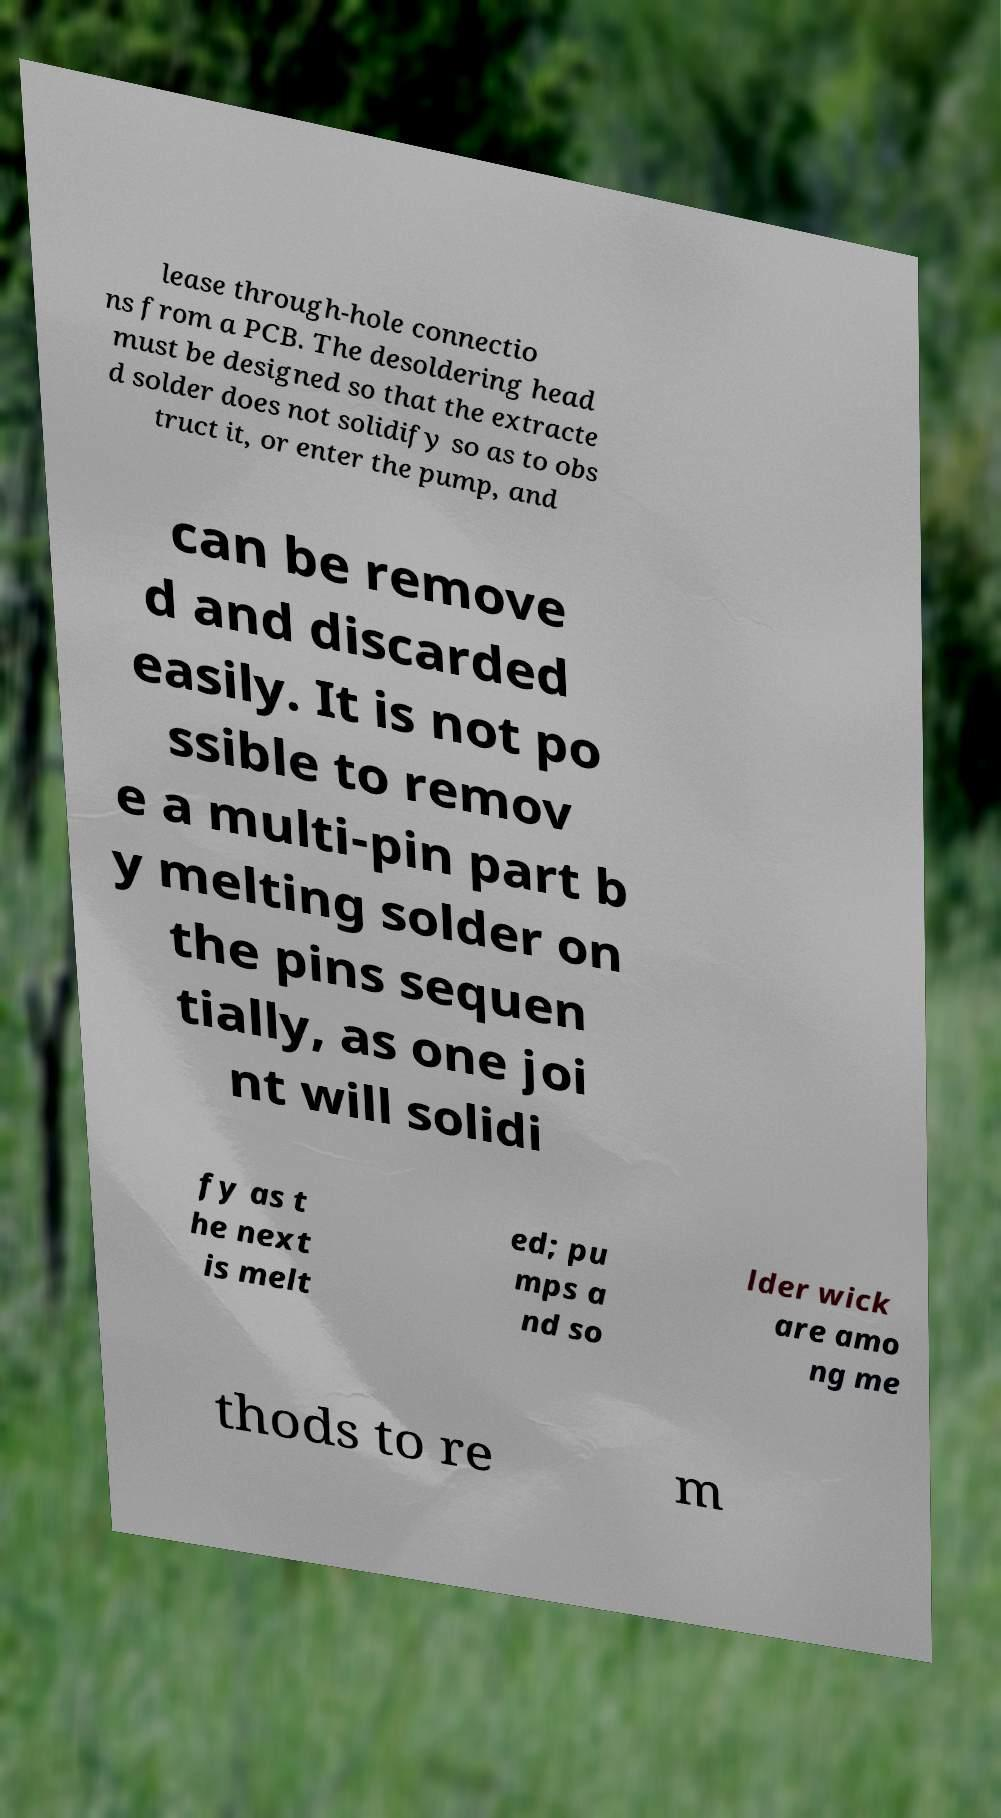There's text embedded in this image that I need extracted. Can you transcribe it verbatim? lease through-hole connectio ns from a PCB. The desoldering head must be designed so that the extracte d solder does not solidify so as to obs truct it, or enter the pump, and can be remove d and discarded easily. It is not po ssible to remov e a multi-pin part b y melting solder on the pins sequen tially, as one joi nt will solidi fy as t he next is melt ed; pu mps a nd so lder wick are amo ng me thods to re m 